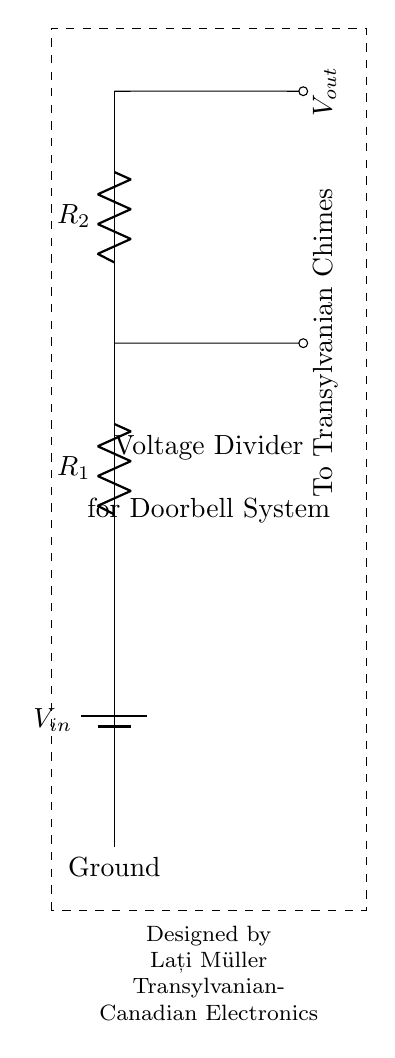What is the input voltage? The circuit diagram labels the input voltage as V_in at the top of the circuit. It does not specify an exact value, but it indicates where the input connects to the circuit.
Answer: V_in What are the resistor values? The diagram includes two resistors labeled as R_1 and R_2, but does not provide specific numerical values for them. They are shown as standard resistors in the circuit diagram.
Answer: R_1 and R_2 Where is the output voltage taken? The output voltage, V_out, is indicated at the connection point between R_1 and R_2, as shown in the diagram. This is a typical point for measuring output in a voltage divider.
Answer: Between R_1 and R_2 What type of circuit is this? The circuit is a voltage divider, which is indicated in the text above the resistor components. It is specifically designed to divide the voltage across the two resistors.
Answer: Voltage divider How does the voltage divider affect the output? In a voltage divider, the output voltage is a fraction of the input voltage, determined by the ratio of the resistor values. This relationship can be described mathematically as V_out = (R_2 / (R_1 + R_2)) * V_in. This results in a lower output voltage compared to the input.
Answer: It lowers the voltage What is the purpose of this circuit? This circuit is designed for a homemade doorbell system that utilizes traditional Transylvanian chimes, as indicated in the text on the right side of the diagram. The circuit is intended to provide a specific voltage to operate the chimes efficiently.
Answer: To operate the doorbell chimes 